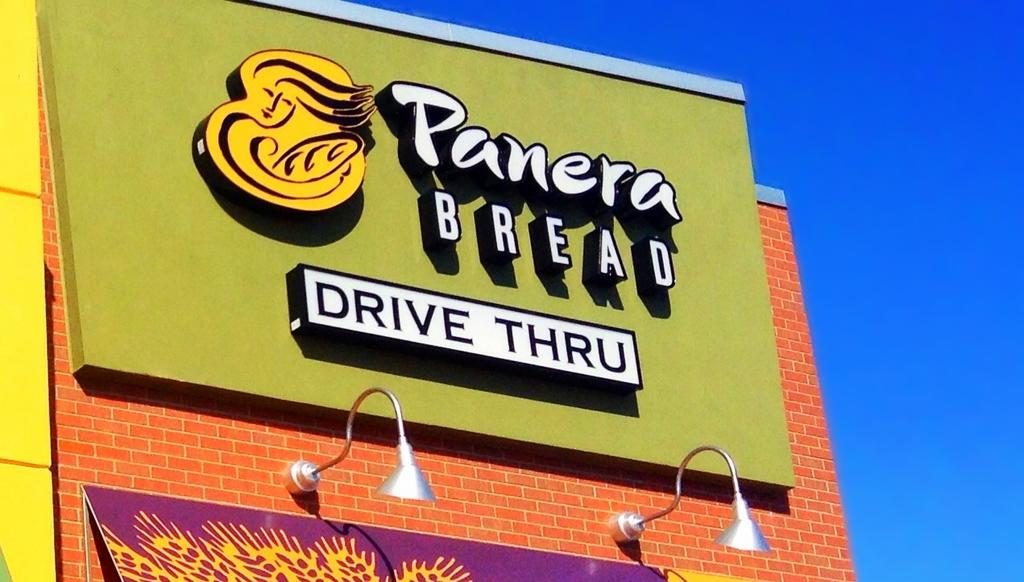<image>
Relay a brief, clear account of the picture shown. Panera bread drive thru restaurant with a light below the sign 